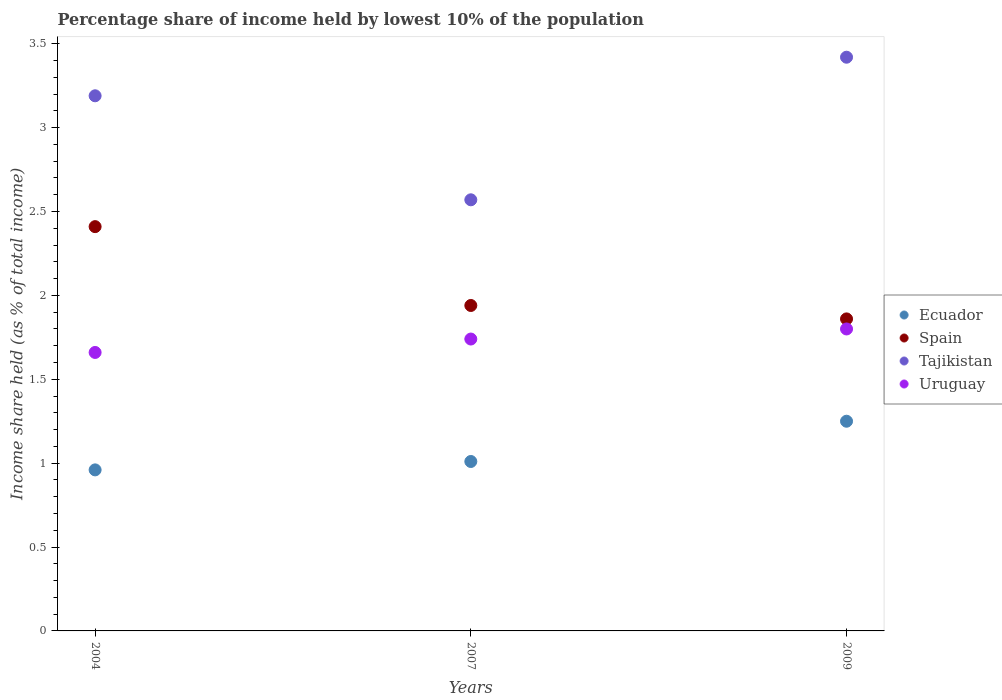Is the number of dotlines equal to the number of legend labels?
Offer a very short reply. Yes. What is the percentage share of income held by lowest 10% of the population in Spain in 2007?
Your answer should be compact. 1.94. Across all years, what is the minimum percentage share of income held by lowest 10% of the population in Tajikistan?
Your answer should be compact. 2.57. What is the total percentage share of income held by lowest 10% of the population in Spain in the graph?
Keep it short and to the point. 6.21. What is the difference between the percentage share of income held by lowest 10% of the population in Tajikistan in 2004 and that in 2007?
Your response must be concise. 0.62. What is the difference between the percentage share of income held by lowest 10% of the population in Uruguay in 2004 and the percentage share of income held by lowest 10% of the population in Ecuador in 2007?
Your answer should be compact. 0.65. What is the average percentage share of income held by lowest 10% of the population in Spain per year?
Give a very brief answer. 2.07. In the year 2007, what is the difference between the percentage share of income held by lowest 10% of the population in Uruguay and percentage share of income held by lowest 10% of the population in Spain?
Keep it short and to the point. -0.2. What is the ratio of the percentage share of income held by lowest 10% of the population in Spain in 2007 to that in 2009?
Make the answer very short. 1.04. Is the percentage share of income held by lowest 10% of the population in Tajikistan in 2004 less than that in 2007?
Your answer should be compact. No. What is the difference between the highest and the second highest percentage share of income held by lowest 10% of the population in Tajikistan?
Your answer should be compact. 0.23. What is the difference between the highest and the lowest percentage share of income held by lowest 10% of the population in Spain?
Provide a succinct answer. 0.55. In how many years, is the percentage share of income held by lowest 10% of the population in Tajikistan greater than the average percentage share of income held by lowest 10% of the population in Tajikistan taken over all years?
Make the answer very short. 2. Is it the case that in every year, the sum of the percentage share of income held by lowest 10% of the population in Ecuador and percentage share of income held by lowest 10% of the population in Tajikistan  is greater than the sum of percentage share of income held by lowest 10% of the population in Uruguay and percentage share of income held by lowest 10% of the population in Spain?
Your answer should be very brief. No. Is it the case that in every year, the sum of the percentage share of income held by lowest 10% of the population in Ecuador and percentage share of income held by lowest 10% of the population in Tajikistan  is greater than the percentage share of income held by lowest 10% of the population in Uruguay?
Offer a very short reply. Yes. How many years are there in the graph?
Your answer should be very brief. 3. Does the graph contain any zero values?
Offer a terse response. No. What is the title of the graph?
Provide a short and direct response. Percentage share of income held by lowest 10% of the population. What is the label or title of the X-axis?
Give a very brief answer. Years. What is the label or title of the Y-axis?
Provide a short and direct response. Income share held (as % of total income). What is the Income share held (as % of total income) in Ecuador in 2004?
Your response must be concise. 0.96. What is the Income share held (as % of total income) of Spain in 2004?
Keep it short and to the point. 2.41. What is the Income share held (as % of total income) in Tajikistan in 2004?
Give a very brief answer. 3.19. What is the Income share held (as % of total income) of Uruguay in 2004?
Provide a succinct answer. 1.66. What is the Income share held (as % of total income) in Ecuador in 2007?
Keep it short and to the point. 1.01. What is the Income share held (as % of total income) of Spain in 2007?
Your response must be concise. 1.94. What is the Income share held (as % of total income) of Tajikistan in 2007?
Your response must be concise. 2.57. What is the Income share held (as % of total income) of Uruguay in 2007?
Provide a short and direct response. 1.74. What is the Income share held (as % of total income) in Spain in 2009?
Your answer should be very brief. 1.86. What is the Income share held (as % of total income) of Tajikistan in 2009?
Your answer should be very brief. 3.42. Across all years, what is the maximum Income share held (as % of total income) in Spain?
Your response must be concise. 2.41. Across all years, what is the maximum Income share held (as % of total income) in Tajikistan?
Keep it short and to the point. 3.42. Across all years, what is the maximum Income share held (as % of total income) of Uruguay?
Provide a short and direct response. 1.8. Across all years, what is the minimum Income share held (as % of total income) in Ecuador?
Provide a succinct answer. 0.96. Across all years, what is the minimum Income share held (as % of total income) of Spain?
Ensure brevity in your answer.  1.86. Across all years, what is the minimum Income share held (as % of total income) of Tajikistan?
Offer a very short reply. 2.57. Across all years, what is the minimum Income share held (as % of total income) of Uruguay?
Offer a very short reply. 1.66. What is the total Income share held (as % of total income) of Ecuador in the graph?
Your answer should be very brief. 3.22. What is the total Income share held (as % of total income) of Spain in the graph?
Offer a very short reply. 6.21. What is the total Income share held (as % of total income) in Tajikistan in the graph?
Offer a terse response. 9.18. What is the total Income share held (as % of total income) of Uruguay in the graph?
Keep it short and to the point. 5.2. What is the difference between the Income share held (as % of total income) in Spain in 2004 and that in 2007?
Your response must be concise. 0.47. What is the difference between the Income share held (as % of total income) of Tajikistan in 2004 and that in 2007?
Provide a succinct answer. 0.62. What is the difference between the Income share held (as % of total income) in Uruguay in 2004 and that in 2007?
Your answer should be compact. -0.08. What is the difference between the Income share held (as % of total income) of Ecuador in 2004 and that in 2009?
Ensure brevity in your answer.  -0.29. What is the difference between the Income share held (as % of total income) in Spain in 2004 and that in 2009?
Keep it short and to the point. 0.55. What is the difference between the Income share held (as % of total income) of Tajikistan in 2004 and that in 2009?
Provide a short and direct response. -0.23. What is the difference between the Income share held (as % of total income) in Uruguay in 2004 and that in 2009?
Make the answer very short. -0.14. What is the difference between the Income share held (as % of total income) of Ecuador in 2007 and that in 2009?
Give a very brief answer. -0.24. What is the difference between the Income share held (as % of total income) of Spain in 2007 and that in 2009?
Offer a very short reply. 0.08. What is the difference between the Income share held (as % of total income) of Tajikistan in 2007 and that in 2009?
Keep it short and to the point. -0.85. What is the difference between the Income share held (as % of total income) in Uruguay in 2007 and that in 2009?
Offer a terse response. -0.06. What is the difference between the Income share held (as % of total income) of Ecuador in 2004 and the Income share held (as % of total income) of Spain in 2007?
Offer a very short reply. -0.98. What is the difference between the Income share held (as % of total income) of Ecuador in 2004 and the Income share held (as % of total income) of Tajikistan in 2007?
Your answer should be very brief. -1.61. What is the difference between the Income share held (as % of total income) of Ecuador in 2004 and the Income share held (as % of total income) of Uruguay in 2007?
Keep it short and to the point. -0.78. What is the difference between the Income share held (as % of total income) of Spain in 2004 and the Income share held (as % of total income) of Tajikistan in 2007?
Offer a terse response. -0.16. What is the difference between the Income share held (as % of total income) of Spain in 2004 and the Income share held (as % of total income) of Uruguay in 2007?
Ensure brevity in your answer.  0.67. What is the difference between the Income share held (as % of total income) in Tajikistan in 2004 and the Income share held (as % of total income) in Uruguay in 2007?
Ensure brevity in your answer.  1.45. What is the difference between the Income share held (as % of total income) in Ecuador in 2004 and the Income share held (as % of total income) in Spain in 2009?
Make the answer very short. -0.9. What is the difference between the Income share held (as % of total income) of Ecuador in 2004 and the Income share held (as % of total income) of Tajikistan in 2009?
Ensure brevity in your answer.  -2.46. What is the difference between the Income share held (as % of total income) in Ecuador in 2004 and the Income share held (as % of total income) in Uruguay in 2009?
Offer a terse response. -0.84. What is the difference between the Income share held (as % of total income) of Spain in 2004 and the Income share held (as % of total income) of Tajikistan in 2009?
Your answer should be compact. -1.01. What is the difference between the Income share held (as % of total income) in Spain in 2004 and the Income share held (as % of total income) in Uruguay in 2009?
Your answer should be very brief. 0.61. What is the difference between the Income share held (as % of total income) of Tajikistan in 2004 and the Income share held (as % of total income) of Uruguay in 2009?
Your response must be concise. 1.39. What is the difference between the Income share held (as % of total income) of Ecuador in 2007 and the Income share held (as % of total income) of Spain in 2009?
Offer a very short reply. -0.85. What is the difference between the Income share held (as % of total income) of Ecuador in 2007 and the Income share held (as % of total income) of Tajikistan in 2009?
Your answer should be compact. -2.41. What is the difference between the Income share held (as % of total income) of Ecuador in 2007 and the Income share held (as % of total income) of Uruguay in 2009?
Ensure brevity in your answer.  -0.79. What is the difference between the Income share held (as % of total income) in Spain in 2007 and the Income share held (as % of total income) in Tajikistan in 2009?
Provide a succinct answer. -1.48. What is the difference between the Income share held (as % of total income) in Spain in 2007 and the Income share held (as % of total income) in Uruguay in 2009?
Offer a very short reply. 0.14. What is the difference between the Income share held (as % of total income) of Tajikistan in 2007 and the Income share held (as % of total income) of Uruguay in 2009?
Your response must be concise. 0.77. What is the average Income share held (as % of total income) in Ecuador per year?
Provide a short and direct response. 1.07. What is the average Income share held (as % of total income) in Spain per year?
Offer a terse response. 2.07. What is the average Income share held (as % of total income) of Tajikistan per year?
Make the answer very short. 3.06. What is the average Income share held (as % of total income) of Uruguay per year?
Your response must be concise. 1.73. In the year 2004, what is the difference between the Income share held (as % of total income) of Ecuador and Income share held (as % of total income) of Spain?
Keep it short and to the point. -1.45. In the year 2004, what is the difference between the Income share held (as % of total income) of Ecuador and Income share held (as % of total income) of Tajikistan?
Keep it short and to the point. -2.23. In the year 2004, what is the difference between the Income share held (as % of total income) of Ecuador and Income share held (as % of total income) of Uruguay?
Give a very brief answer. -0.7. In the year 2004, what is the difference between the Income share held (as % of total income) of Spain and Income share held (as % of total income) of Tajikistan?
Your answer should be compact. -0.78. In the year 2004, what is the difference between the Income share held (as % of total income) in Tajikistan and Income share held (as % of total income) in Uruguay?
Keep it short and to the point. 1.53. In the year 2007, what is the difference between the Income share held (as % of total income) of Ecuador and Income share held (as % of total income) of Spain?
Your answer should be very brief. -0.93. In the year 2007, what is the difference between the Income share held (as % of total income) in Ecuador and Income share held (as % of total income) in Tajikistan?
Keep it short and to the point. -1.56. In the year 2007, what is the difference between the Income share held (as % of total income) of Ecuador and Income share held (as % of total income) of Uruguay?
Provide a short and direct response. -0.73. In the year 2007, what is the difference between the Income share held (as % of total income) in Spain and Income share held (as % of total income) in Tajikistan?
Ensure brevity in your answer.  -0.63. In the year 2007, what is the difference between the Income share held (as % of total income) in Spain and Income share held (as % of total income) in Uruguay?
Your response must be concise. 0.2. In the year 2007, what is the difference between the Income share held (as % of total income) of Tajikistan and Income share held (as % of total income) of Uruguay?
Ensure brevity in your answer.  0.83. In the year 2009, what is the difference between the Income share held (as % of total income) of Ecuador and Income share held (as % of total income) of Spain?
Ensure brevity in your answer.  -0.61. In the year 2009, what is the difference between the Income share held (as % of total income) in Ecuador and Income share held (as % of total income) in Tajikistan?
Give a very brief answer. -2.17. In the year 2009, what is the difference between the Income share held (as % of total income) of Ecuador and Income share held (as % of total income) of Uruguay?
Keep it short and to the point. -0.55. In the year 2009, what is the difference between the Income share held (as % of total income) of Spain and Income share held (as % of total income) of Tajikistan?
Offer a terse response. -1.56. In the year 2009, what is the difference between the Income share held (as % of total income) in Spain and Income share held (as % of total income) in Uruguay?
Your response must be concise. 0.06. In the year 2009, what is the difference between the Income share held (as % of total income) in Tajikistan and Income share held (as % of total income) in Uruguay?
Make the answer very short. 1.62. What is the ratio of the Income share held (as % of total income) in Ecuador in 2004 to that in 2007?
Your answer should be very brief. 0.95. What is the ratio of the Income share held (as % of total income) of Spain in 2004 to that in 2007?
Give a very brief answer. 1.24. What is the ratio of the Income share held (as % of total income) in Tajikistan in 2004 to that in 2007?
Provide a succinct answer. 1.24. What is the ratio of the Income share held (as % of total income) of Uruguay in 2004 to that in 2007?
Give a very brief answer. 0.95. What is the ratio of the Income share held (as % of total income) of Ecuador in 2004 to that in 2009?
Provide a short and direct response. 0.77. What is the ratio of the Income share held (as % of total income) in Spain in 2004 to that in 2009?
Give a very brief answer. 1.3. What is the ratio of the Income share held (as % of total income) of Tajikistan in 2004 to that in 2009?
Your response must be concise. 0.93. What is the ratio of the Income share held (as % of total income) of Uruguay in 2004 to that in 2009?
Your answer should be very brief. 0.92. What is the ratio of the Income share held (as % of total income) of Ecuador in 2007 to that in 2009?
Your answer should be compact. 0.81. What is the ratio of the Income share held (as % of total income) in Spain in 2007 to that in 2009?
Make the answer very short. 1.04. What is the ratio of the Income share held (as % of total income) in Tajikistan in 2007 to that in 2009?
Your answer should be compact. 0.75. What is the ratio of the Income share held (as % of total income) of Uruguay in 2007 to that in 2009?
Keep it short and to the point. 0.97. What is the difference between the highest and the second highest Income share held (as % of total income) in Ecuador?
Provide a succinct answer. 0.24. What is the difference between the highest and the second highest Income share held (as % of total income) in Spain?
Give a very brief answer. 0.47. What is the difference between the highest and the second highest Income share held (as % of total income) in Tajikistan?
Keep it short and to the point. 0.23. What is the difference between the highest and the second highest Income share held (as % of total income) in Uruguay?
Provide a short and direct response. 0.06. What is the difference between the highest and the lowest Income share held (as % of total income) of Ecuador?
Provide a succinct answer. 0.29. What is the difference between the highest and the lowest Income share held (as % of total income) of Spain?
Keep it short and to the point. 0.55. What is the difference between the highest and the lowest Income share held (as % of total income) in Uruguay?
Keep it short and to the point. 0.14. 